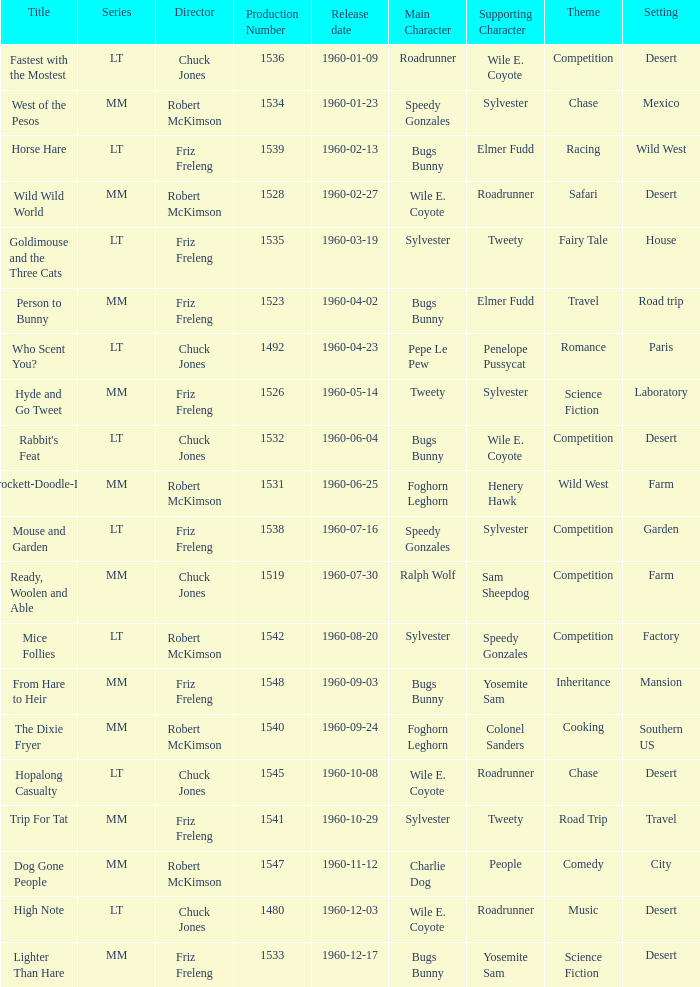What is the production number for the episode directed by Robert McKimson named Mice Follies? 1.0. 